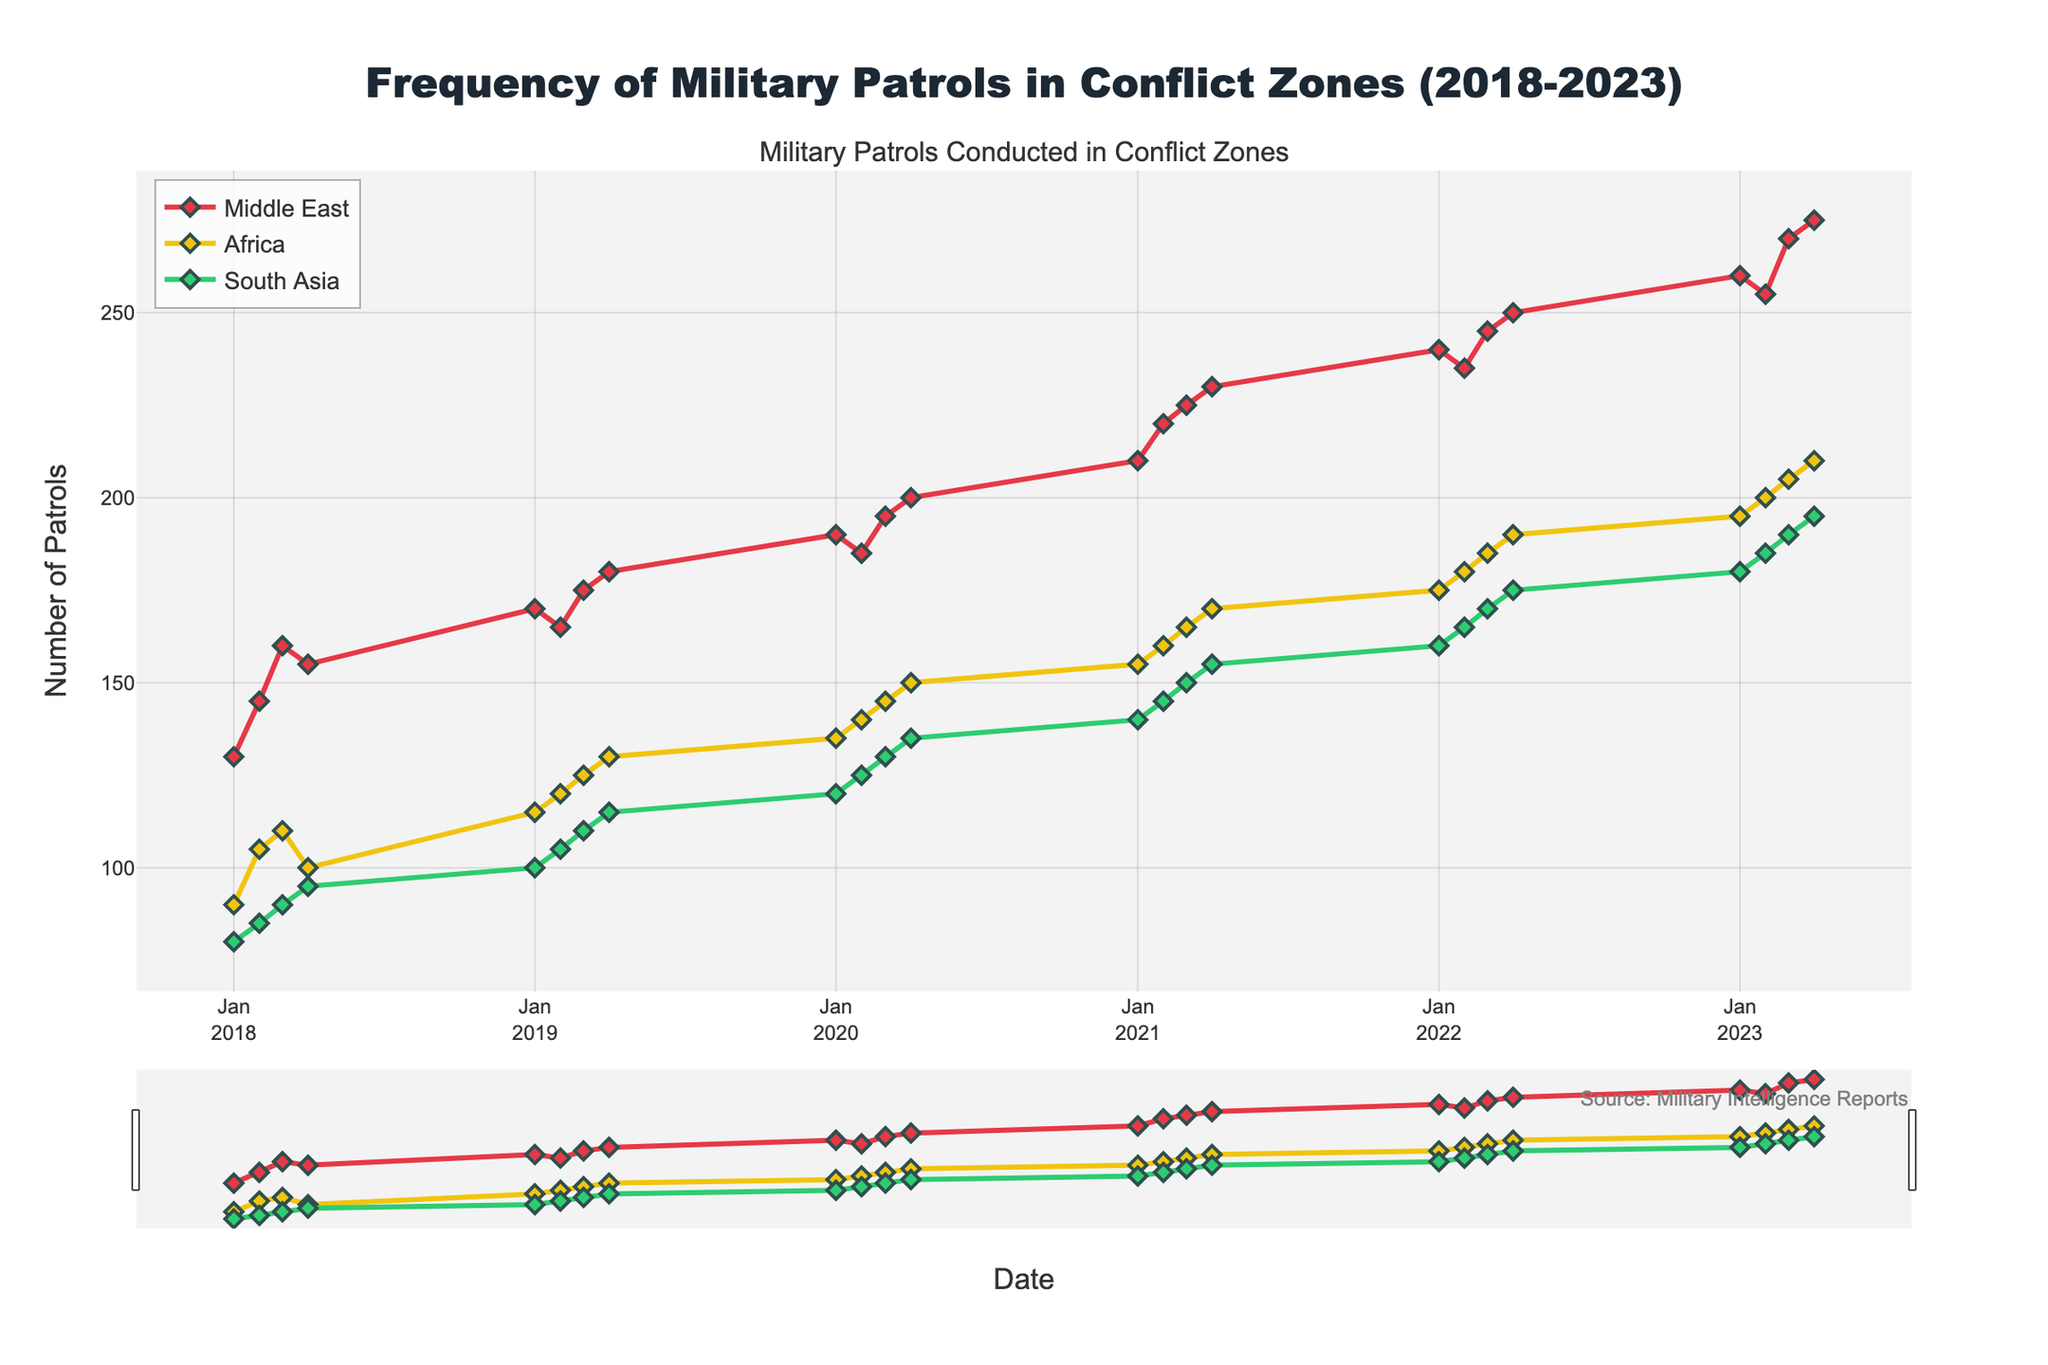What is the title of the figure? The title is displayed at the top center of the figure, highlighting the main subject. It reads "Frequency of Military Patrols in Conflict Zones (2018-2023)".
Answer: Frequency of Military Patrols in Conflict Zones (2018-2023) How many regions are represented in the plot? The plot has a legend at the top left, showing three regions: Middle East, Africa, and South Asia. The colors for each region are red, yellow, and green respectively.
Answer: 3 Which region has the highest number of patrols in Q4 2023? In the plot, locate the data points for Q4 2023 across the three regions and observe the y-values. The Middle East has the highest value with 275 patrols.
Answer: Middle East What is the approximate number of patrols conducted in the Middle East in Q1 2022? By finding the data point for Q1 2022 in the Middle East's time series line, the corresponding y-value is around 240 patrols.
Answer: 240 How does the number of patrols conducted in Africa in Q1 2020 compare to those in South Asia in the same period? Locate the data points for Q1 2020 for both Africa and South Asia. Africa has 135 patrols, while South Asia has 120 patrols. Africa has more patrols than South Asia.
Answer: Africa has more What is the average number of patrols conducted in the Middle East in 2019? Summing the quarterly patrols in the Middle East for 2019 (170 + 165 + 175 + 180) equals 690. There are four quarters, so the average is 690 / 4 = 172.5 patrols.
Answer: 172.5 Which region shows a consistent increase in the number of patrols conducted from 2018 to 2023? By observing the trends in the plot for each region, both the Middle East and Africa consistently increase, but the Middle East shows the most regular and steep rise throughout the period.
Answer: Middle East What can you infer about the trend in the number of patrols in South Asia between 2021 and 2023? From the plot, the trend line for South Asia shows a steady increase. The patrols rise from approximately 140 in Q1 2021 to about 195 in Q4 2023 indicating a positive trend.
Answer: Steady increase During which quarter and year did Africa reach 150 patrols? By examining Africa's time series, the data point for 150 patrols is in Q4 of 2020.
Answer: Q4 2020 Between which two consecutive quarters in the Middle East was the increase in patrols the highest? By identifying the slopes between consecutive quarters, Q4 2022 to Q1 2023 shows the highest increase, from 250 to 260 patrols, a jump of 10 patrols.
Answer: Q4 2022 to Q1 2023 